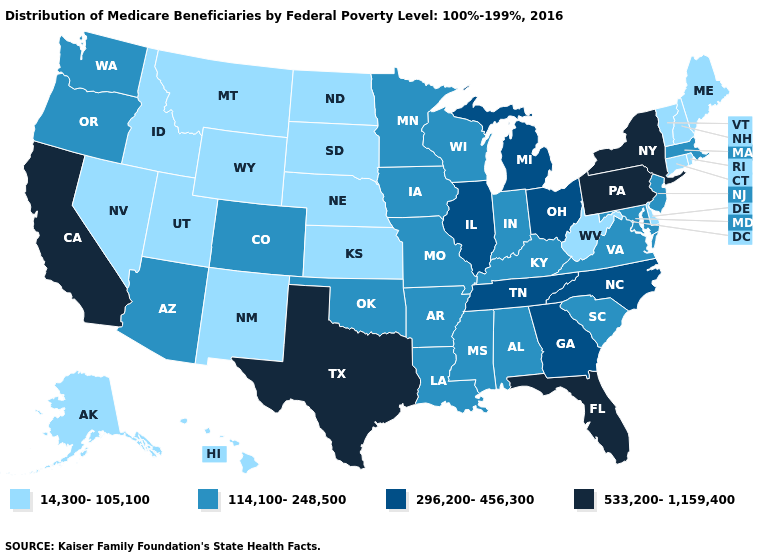What is the value of New York?
Quick response, please. 533,200-1,159,400. What is the lowest value in the USA?
Keep it brief. 14,300-105,100. Name the states that have a value in the range 296,200-456,300?
Short answer required. Georgia, Illinois, Michigan, North Carolina, Ohio, Tennessee. Among the states that border Iowa , which have the lowest value?
Quick response, please. Nebraska, South Dakota. Does the first symbol in the legend represent the smallest category?
Concise answer only. Yes. What is the lowest value in the USA?
Concise answer only. 14,300-105,100. Does Utah have a lower value than Delaware?
Give a very brief answer. No. What is the lowest value in the South?
Short answer required. 14,300-105,100. Does Hawaii have a lower value than New Jersey?
Quick response, please. Yes. Which states hav the highest value in the MidWest?
Be succinct. Illinois, Michigan, Ohio. What is the value of New Mexico?
Give a very brief answer. 14,300-105,100. Among the states that border South Carolina , which have the highest value?
Give a very brief answer. Georgia, North Carolina. What is the value of Hawaii?
Give a very brief answer. 14,300-105,100. What is the value of Washington?
Give a very brief answer. 114,100-248,500. What is the highest value in the South ?
Quick response, please. 533,200-1,159,400. 